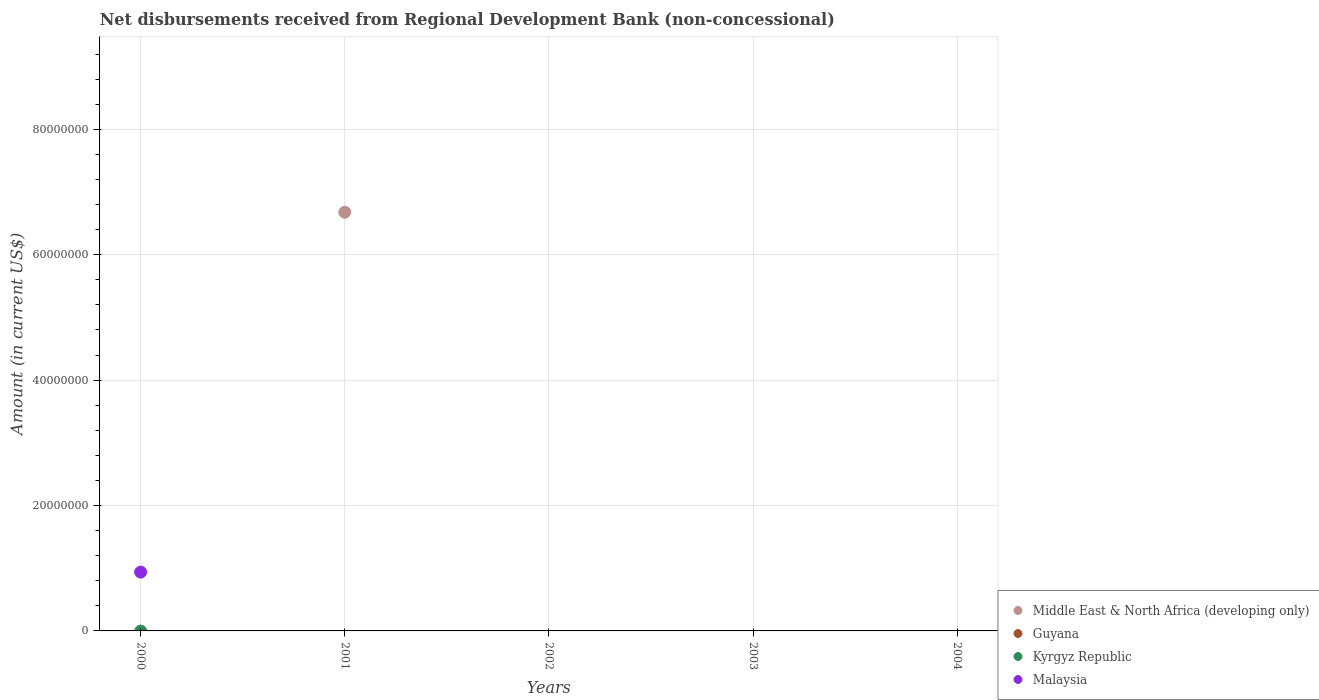Is the number of dotlines equal to the number of legend labels?
Your answer should be compact. No. Across all years, what is the maximum amount of disbursements received from Regional Development Bank in Middle East & North Africa (developing only)?
Provide a short and direct response. 6.68e+07. Across all years, what is the minimum amount of disbursements received from Regional Development Bank in Kyrgyz Republic?
Offer a very short reply. 0. What is the difference between the amount of disbursements received from Regional Development Bank in Guyana in 2004 and the amount of disbursements received from Regional Development Bank in Kyrgyz Republic in 2003?
Your answer should be compact. 0. In how many years, is the amount of disbursements received from Regional Development Bank in Guyana greater than 8000000 US$?
Provide a short and direct response. 0. What is the difference between the highest and the lowest amount of disbursements received from Regional Development Bank in Middle East & North Africa (developing only)?
Keep it short and to the point. 6.68e+07. Is it the case that in every year, the sum of the amount of disbursements received from Regional Development Bank in Guyana and amount of disbursements received from Regional Development Bank in Malaysia  is greater than the amount of disbursements received from Regional Development Bank in Middle East & North Africa (developing only)?
Offer a terse response. No. Is the amount of disbursements received from Regional Development Bank in Guyana strictly greater than the amount of disbursements received from Regional Development Bank in Malaysia over the years?
Keep it short and to the point. No. Is the amount of disbursements received from Regional Development Bank in Malaysia strictly less than the amount of disbursements received from Regional Development Bank in Kyrgyz Republic over the years?
Provide a succinct answer. No. How many dotlines are there?
Keep it short and to the point. 2. How many years are there in the graph?
Give a very brief answer. 5. What is the difference between two consecutive major ticks on the Y-axis?
Offer a very short reply. 2.00e+07. Are the values on the major ticks of Y-axis written in scientific E-notation?
Keep it short and to the point. No. Does the graph contain any zero values?
Provide a short and direct response. Yes. Does the graph contain grids?
Make the answer very short. Yes. Where does the legend appear in the graph?
Your response must be concise. Bottom right. What is the title of the graph?
Offer a terse response. Net disbursements received from Regional Development Bank (non-concessional). What is the label or title of the Y-axis?
Provide a short and direct response. Amount (in current US$). What is the Amount (in current US$) of Middle East & North Africa (developing only) in 2000?
Ensure brevity in your answer.  0. What is the Amount (in current US$) of Guyana in 2000?
Keep it short and to the point. 0. What is the Amount (in current US$) of Malaysia in 2000?
Keep it short and to the point. 9.38e+06. What is the Amount (in current US$) in Middle East & North Africa (developing only) in 2001?
Provide a succinct answer. 6.68e+07. What is the Amount (in current US$) of Malaysia in 2001?
Provide a short and direct response. 0. What is the Amount (in current US$) in Middle East & North Africa (developing only) in 2002?
Your response must be concise. 0. What is the Amount (in current US$) in Guyana in 2002?
Give a very brief answer. 0. What is the Amount (in current US$) in Kyrgyz Republic in 2002?
Provide a succinct answer. 0. What is the Amount (in current US$) of Malaysia in 2002?
Give a very brief answer. 0. What is the Amount (in current US$) of Guyana in 2003?
Offer a terse response. 0. What is the Amount (in current US$) in Malaysia in 2003?
Provide a short and direct response. 0. What is the Amount (in current US$) of Guyana in 2004?
Provide a succinct answer. 0. Across all years, what is the maximum Amount (in current US$) in Middle East & North Africa (developing only)?
Give a very brief answer. 6.68e+07. Across all years, what is the maximum Amount (in current US$) of Malaysia?
Give a very brief answer. 9.38e+06. Across all years, what is the minimum Amount (in current US$) in Middle East & North Africa (developing only)?
Ensure brevity in your answer.  0. What is the total Amount (in current US$) in Middle East & North Africa (developing only) in the graph?
Give a very brief answer. 6.68e+07. What is the total Amount (in current US$) in Guyana in the graph?
Provide a short and direct response. 0. What is the total Amount (in current US$) in Malaysia in the graph?
Make the answer very short. 9.38e+06. What is the average Amount (in current US$) of Middle East & North Africa (developing only) per year?
Make the answer very short. 1.34e+07. What is the average Amount (in current US$) of Malaysia per year?
Offer a very short reply. 1.88e+06. What is the difference between the highest and the lowest Amount (in current US$) of Middle East & North Africa (developing only)?
Your answer should be compact. 6.68e+07. What is the difference between the highest and the lowest Amount (in current US$) of Malaysia?
Provide a short and direct response. 9.38e+06. 